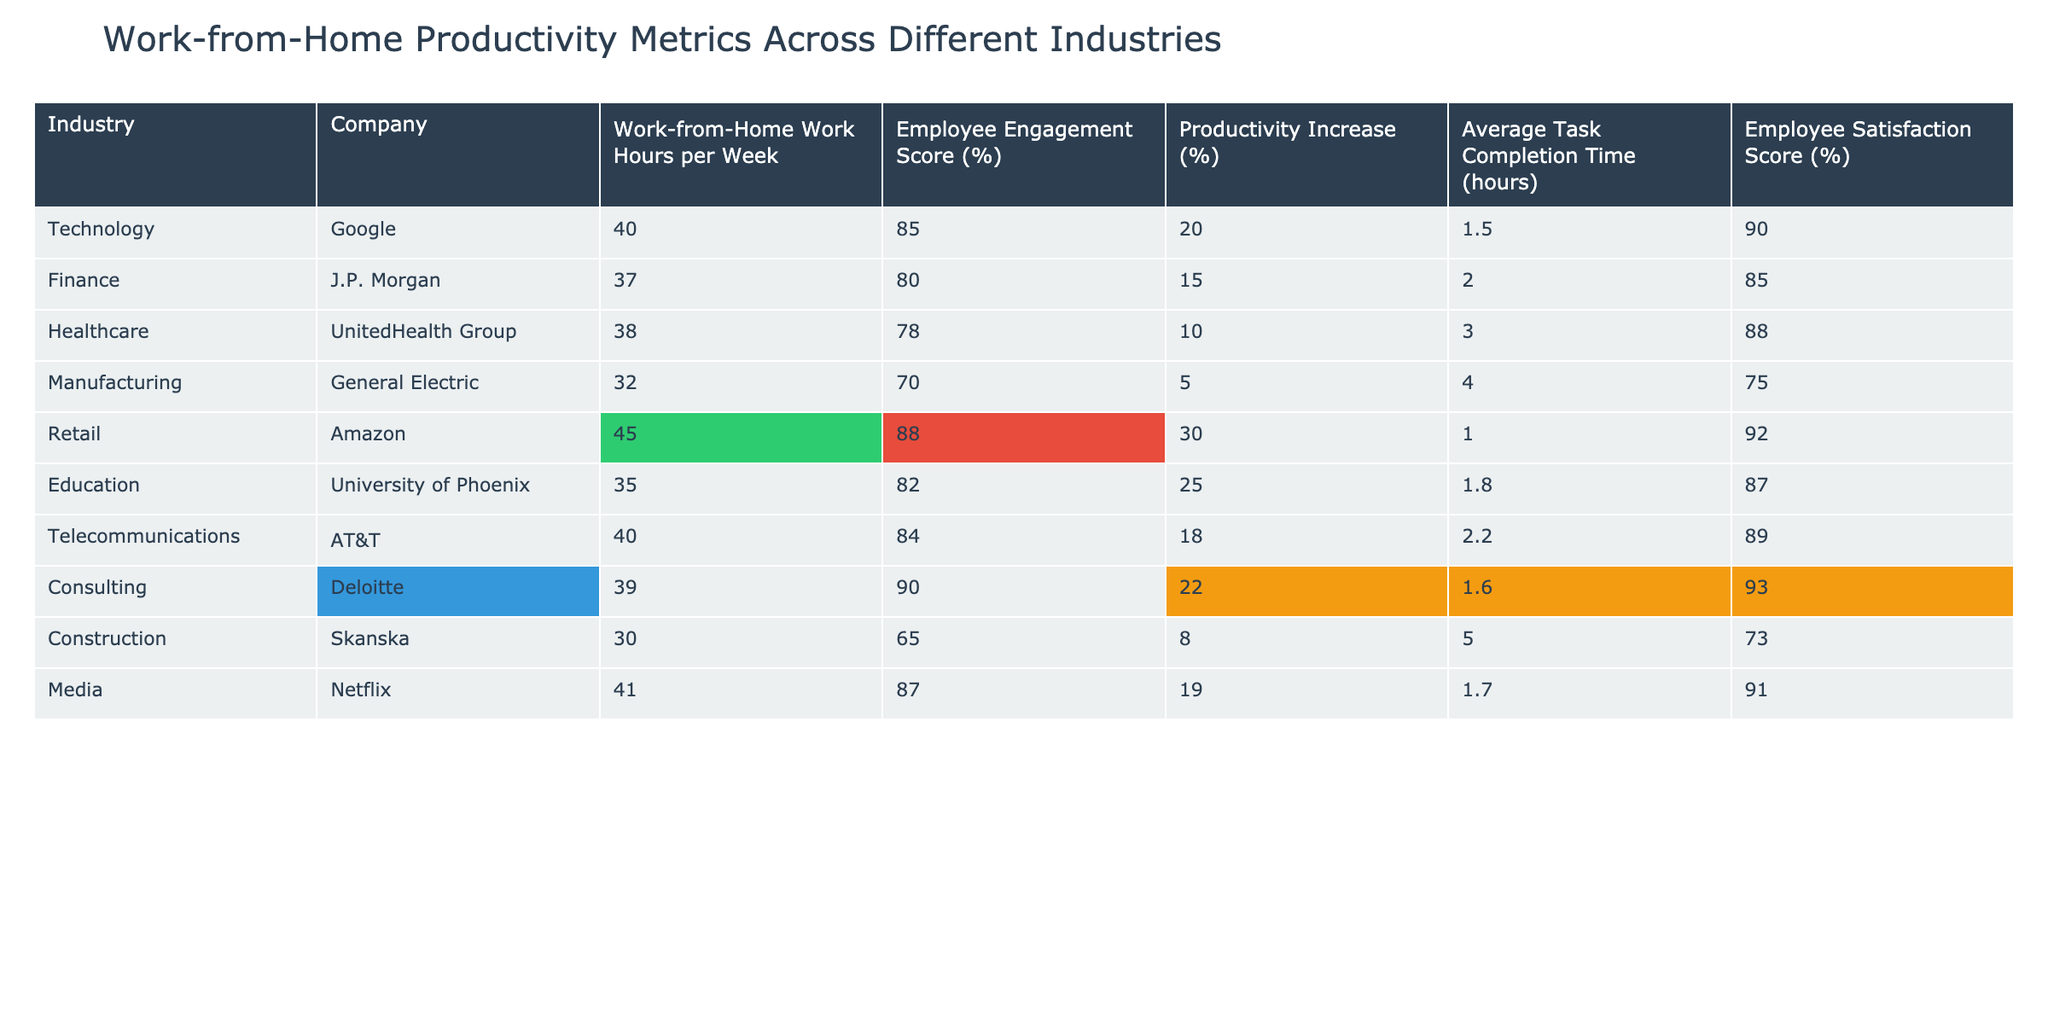What is the highest Employee Engagement Score? The maximum value in the Employee Engagement Score column is from Deloitte at 90%.
Answer: 90% Which industry has the lowest Average Task Completion Time? The Average Task Completion Time is lowest at General Electric with 4 hours.
Answer: 4 hours What is the Productivity Increase for Retail companies? The table shows Amazon in the Retail industry with a Productivity Increase of 30%.
Answer: 30% Is the Employee Satisfaction Score for the Technology industry greater than 85%? Google has an Employee Satisfaction Score of 90%, which is greater than 85%.
Answer: Yes What is the average Work-from-Home Work Hours per Week for all industries? Total work hours are 40 + 37 + 38 + 32 + 45 + 35 + 40 + 39 + 30 + 41 =  387. There are 10 industries, so the average is 387/10 = 38.7 hours.
Answer: 38.7 hours Which industry has both the highest Employee Engagement Score and the highest Employee Satisfaction Score? Deloitte has the highest Employee Engagement Score at 90% and also has a high Employee Satisfaction Score at 93%.
Answer: Consulting (Deloitte) What is the difference in Productivity Increase between Retail and Manufacturing? The Productivity Increase for Amazon (Retail) is 30%, while for General Electric (Manufacturing) it is 5%. The difference is 30% - 5% = 25%.
Answer: 25% Which company has the second-highest Employee Satisfaction Score? The table shows that AT&T has an Employee Satisfaction Score of 89%, which is the second highest after Deloitte’s 93%.
Answer: AT&T If we combine the Work-from-Home Work Hours per Week of Technology and Finance industries, what is their total? Adding the hours: 40 (Google) + 37 (J.P. Morgan) = 77 hours.
Answer: 77 hours Which industry has the lowest Employee Engagement Score, and what is its value? The lowest Employee Engagement Score is from Skanska in Construction at 65%.
Answer: 65% 